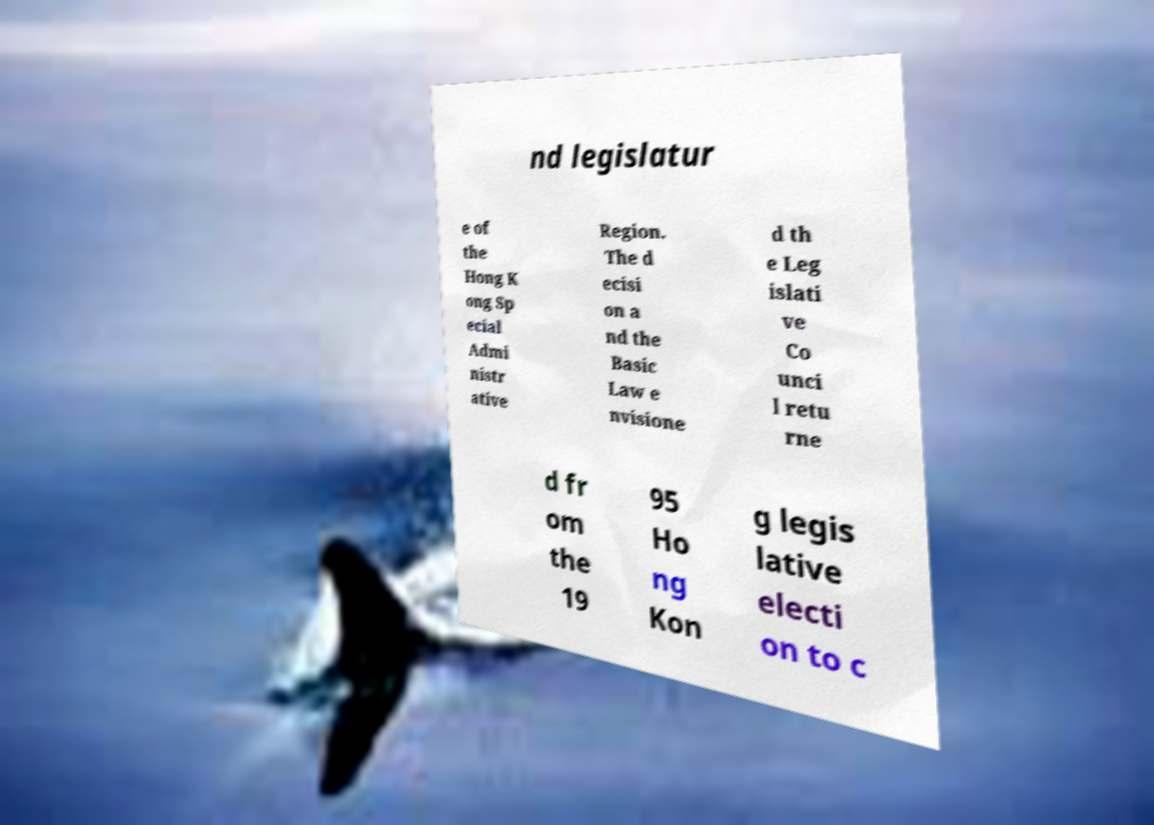Please read and relay the text visible in this image. What does it say? nd legislatur e of the Hong K ong Sp ecial Admi nistr ative Region. The d ecisi on a nd the Basic Law e nvisione d th e Leg islati ve Co unci l retu rne d fr om the 19 95 Ho ng Kon g legis lative electi on to c 